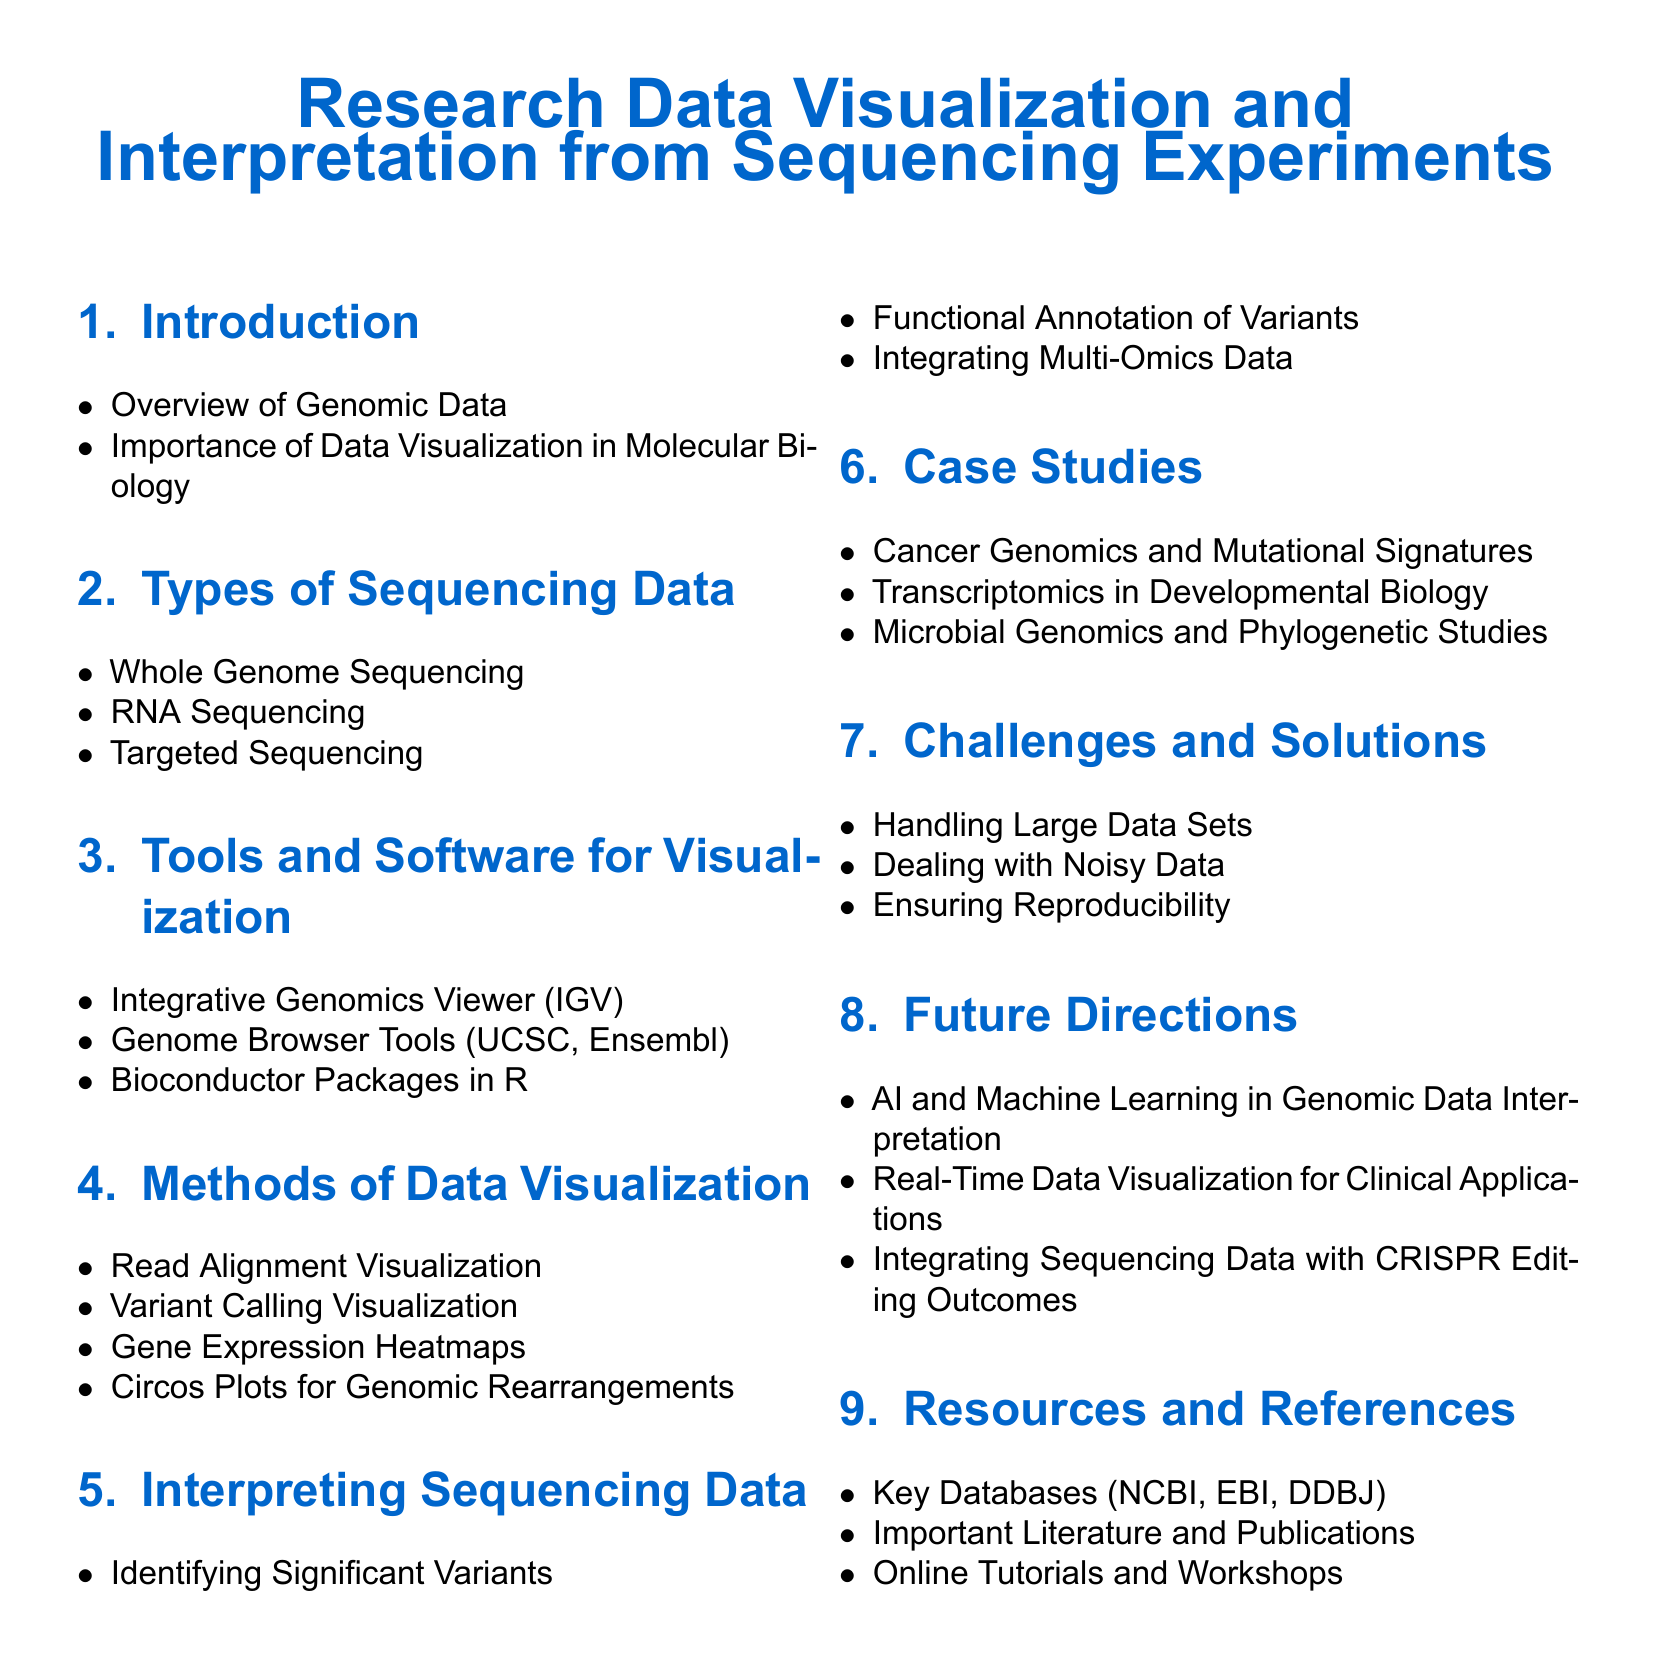What is the title of the document? The title summarizes the main subject of the document which is about visualizing and interpreting sequencing data.
Answer: Research Data Visualization and Interpretation from Sequencing Experiments How many types of sequencing data are mentioned? The document lists specifically the different types of sequencing data found in molecular biology.
Answer: Three What tool is used for integrative genomic viewing? This refers to a specific software tool mentioned that allows visualization of genomic data.
Answer: Integrative Genomics Viewer (IGV) Which section addresses handling large data sets? This section is dedicated to discussing the challenges faced when working with sequencing data.
Answer: Challenges and Solutions What are the case studies focused on? This part highlights specific applications of genomic data analysis in various fields of research.
Answer: Cancer Genomics and Mutational Signatures Which future direction involves AI? This direction discusses the application of technology in genomic data interpretation.
Answer: AI and Machine Learning in Genomic Data Interpretation What is a common visualization method for gene expression? This visualization technique is used to represent gene expression levels across samples.
Answer: Gene Expression Heatmaps Which databases are listed as key resources? This refers to specific databases important for genomic research mentioned in the document.
Answer: NCBI, EBI, DDBJ What is the significance of data visualization in molecular biology? This explains the importance of visually representing data to interpret results effectively.
Answer: Importance of Data Visualization in Molecular Biology 